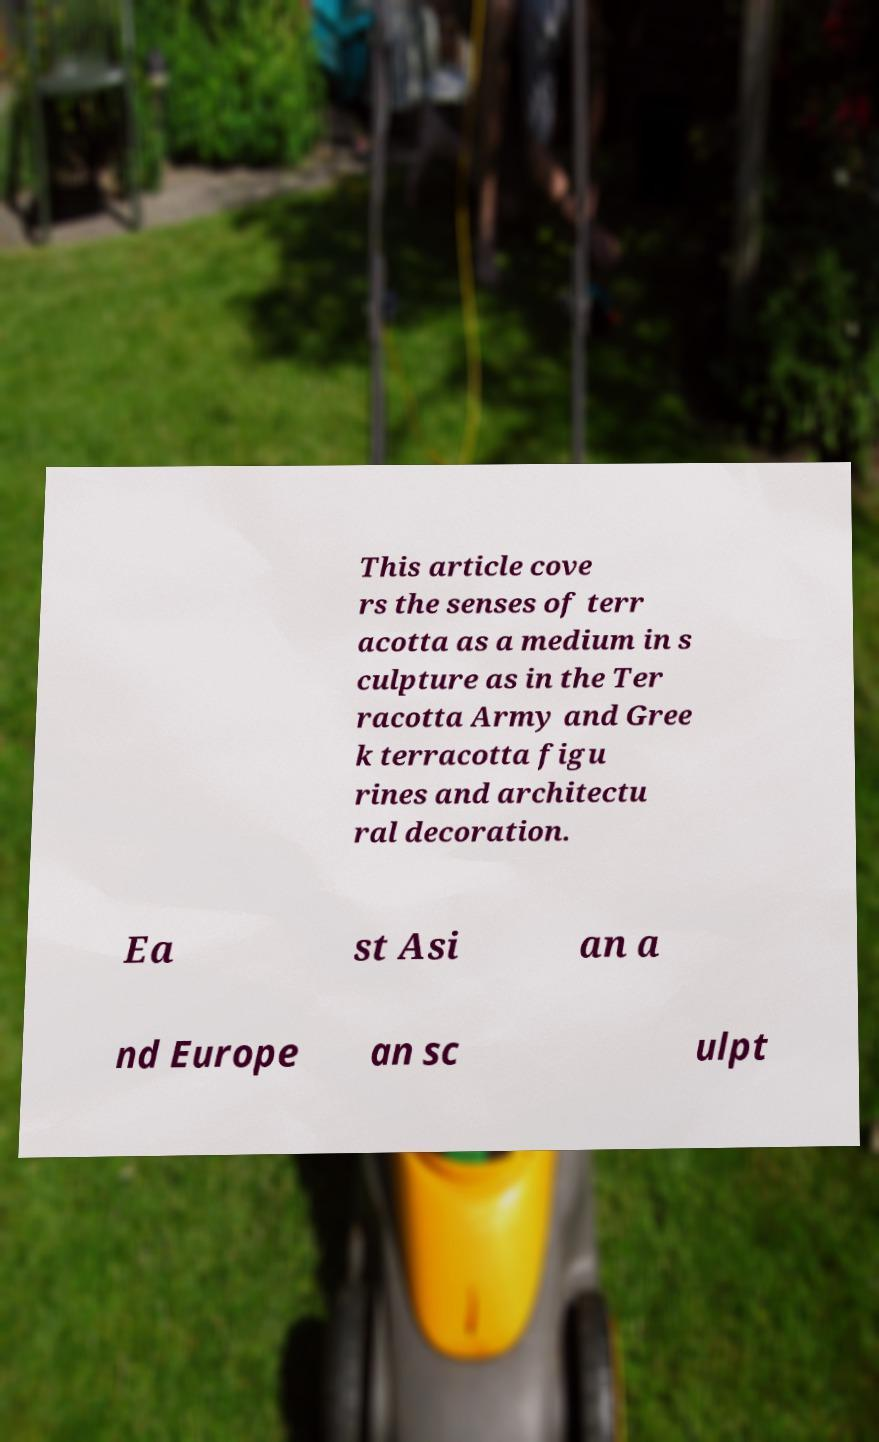Can you accurately transcribe the text from the provided image for me? This article cove rs the senses of terr acotta as a medium in s culpture as in the Ter racotta Army and Gree k terracotta figu rines and architectu ral decoration. Ea st Asi an a nd Europe an sc ulpt 